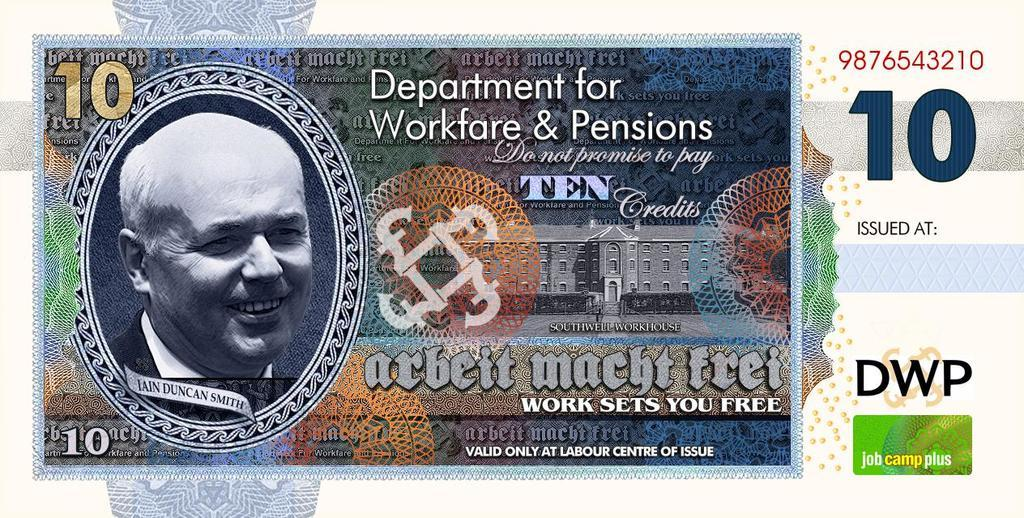What is the main subject of the image? The main subject of the image is a currency note with numbers and text. Can you describe the person in the image? There is a person smiling on the left side of the image. What structure is located in the middle of the image? There is a building in the middle of the image. What type of impulse can be seen affecting the rhythm of the building in the image? There is no impulse or rhythm affecting the building in the image; it is a static structure. 